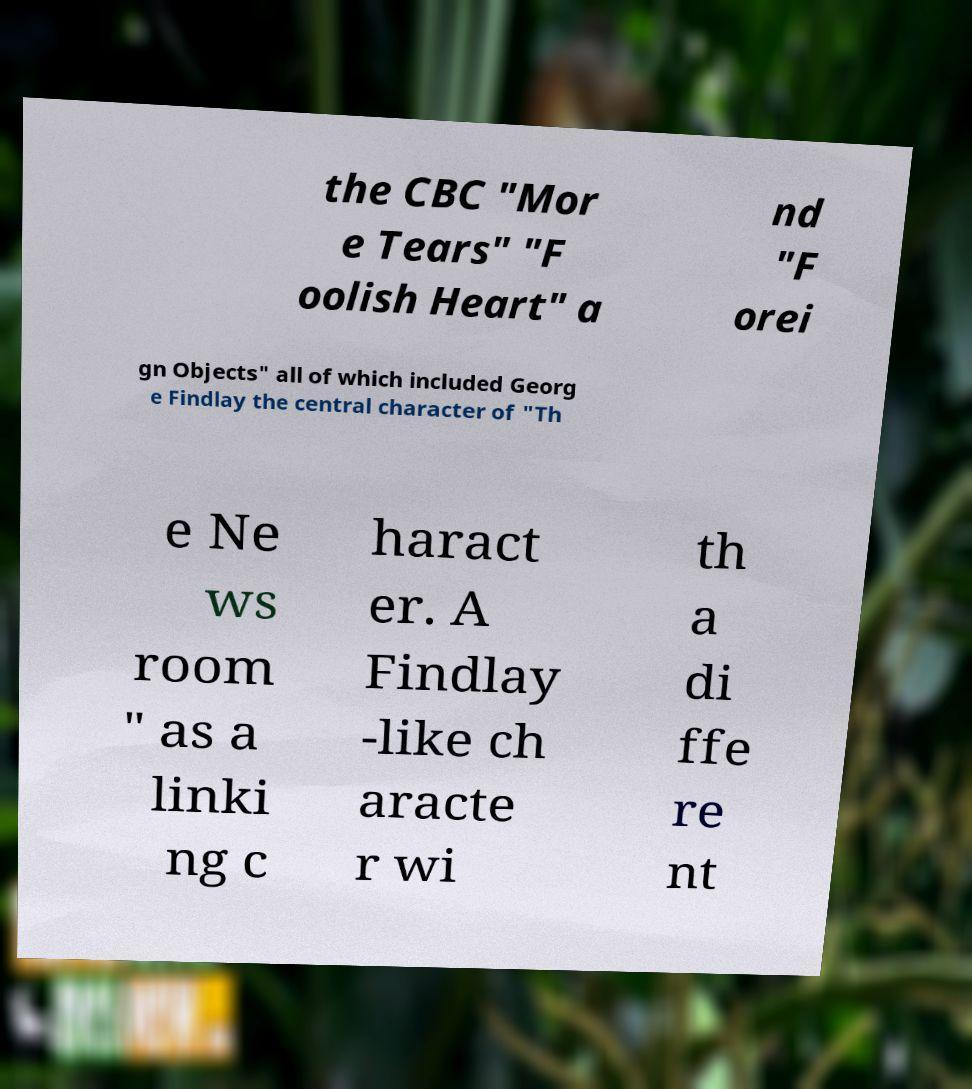What messages or text are displayed in this image? I need them in a readable, typed format. the CBC "Mor e Tears" "F oolish Heart" a nd "F orei gn Objects" all of which included Georg e Findlay the central character of "Th e Ne ws room " as a linki ng c haract er. A Findlay -like ch aracte r wi th a di ffe re nt 